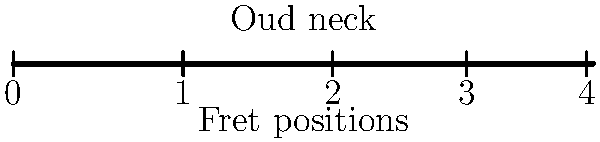As a novice oud player inspired by Joseph Tawadros, you're studying fret placement. The diagram shows an oud neck with fret positions marked. Given that the scale length (distance from nut to bridge) is 60 cm, and fret positions follow the formula $L(1 - 2^{-n/12})$ where $L$ is the scale length and $n$ is the fret number, calculate the distance from the nut to the 5th fret in centimeters. To solve this problem, we'll follow these steps:

1. Understand the given information:
   - Scale length (L) = 60 cm
   - Formula for fret position: $L(1 - 2^{-n/12})$
   - We need to find the position of the 5th fret (n = 5)

2. Substitute the values into the formula:
   Distance to 5th fret = $60(1 - 2^{-5/12})$

3. Calculate the exponent:
   $-5/12 \approx -0.4167$

4. Calculate $2^{-5/12}$:
   $2^{-0.4167} \approx 0.7491$

5. Subtract this value from 1:
   $1 - 0.7491 = 0.2509$

6. Multiply by the scale length:
   $60 * 0.2509 = 15.054$ cm

Therefore, the distance from the nut to the 5th fret is approximately 15.05 cm.
Answer: 15.05 cm 